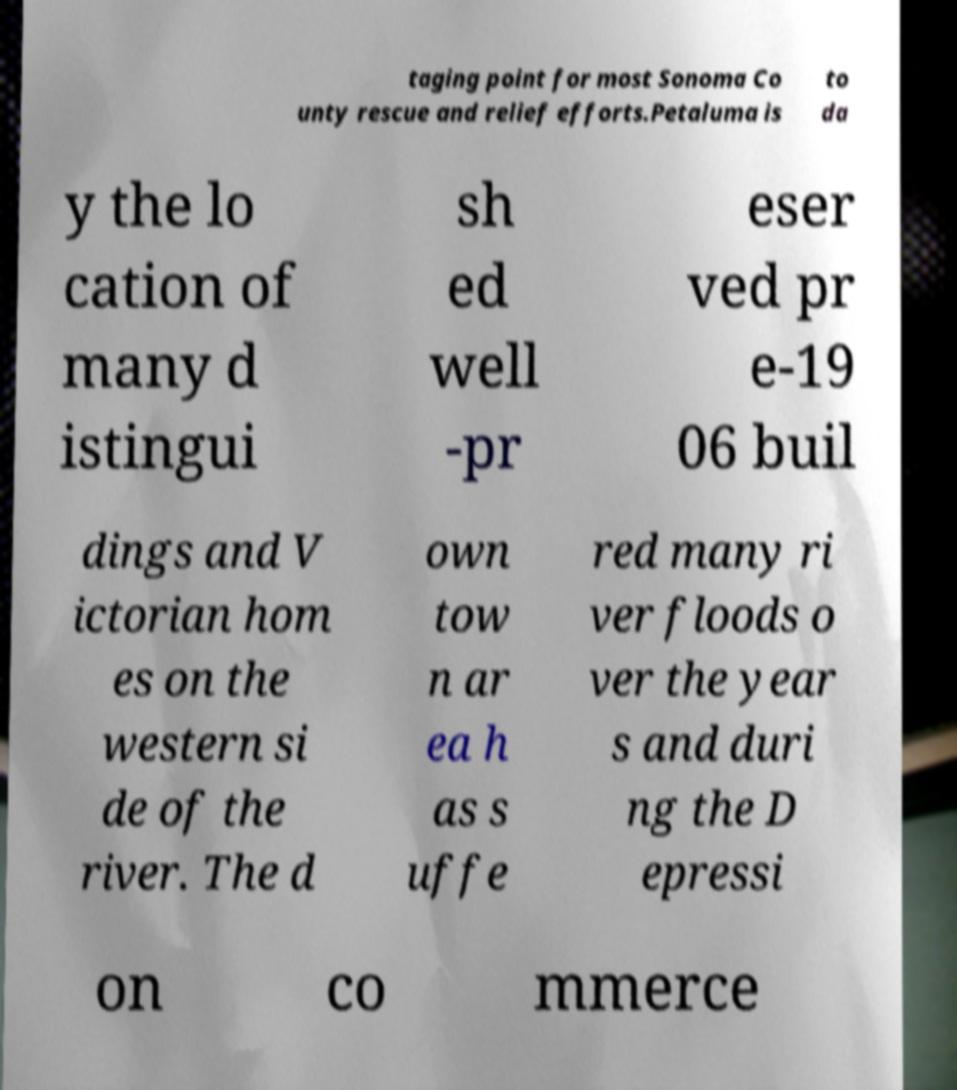Could you assist in decoding the text presented in this image and type it out clearly? taging point for most Sonoma Co unty rescue and relief efforts.Petaluma is to da y the lo cation of many d istingui sh ed well -pr eser ved pr e-19 06 buil dings and V ictorian hom es on the western si de of the river. The d own tow n ar ea h as s uffe red many ri ver floods o ver the year s and duri ng the D epressi on co mmerce 